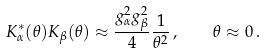Convert formula to latex. <formula><loc_0><loc_0><loc_500><loc_500>K _ { \alpha } ^ { * } ( \theta ) K _ { \beta } ( \theta ) \approx \frac { g _ { \alpha } ^ { 2 } g _ { \beta } ^ { 2 } } { 4 } \frac { 1 } { \theta ^ { 2 } } \, , \quad \theta \approx 0 \, .</formula> 